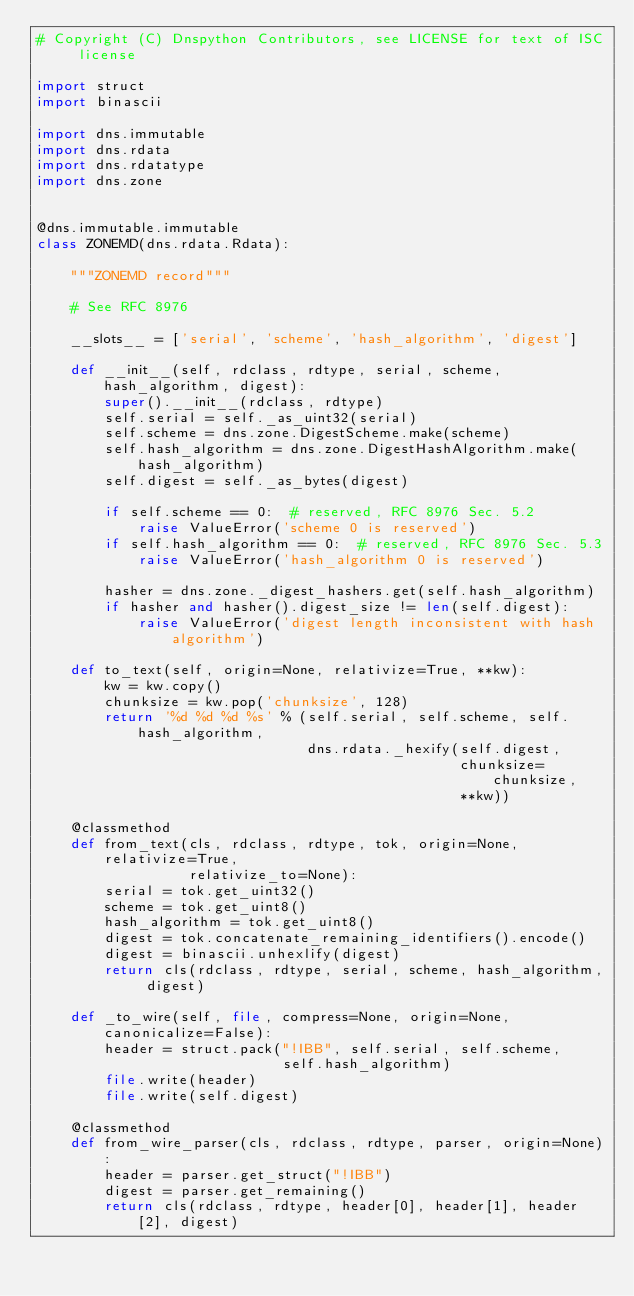Convert code to text. <code><loc_0><loc_0><loc_500><loc_500><_Python_># Copyright (C) Dnspython Contributors, see LICENSE for text of ISC license

import struct
import binascii

import dns.immutable
import dns.rdata
import dns.rdatatype
import dns.zone


@dns.immutable.immutable
class ZONEMD(dns.rdata.Rdata):

    """ZONEMD record"""

    # See RFC 8976

    __slots__ = ['serial', 'scheme', 'hash_algorithm', 'digest']

    def __init__(self, rdclass, rdtype, serial, scheme, hash_algorithm, digest):
        super().__init__(rdclass, rdtype)
        self.serial = self._as_uint32(serial)
        self.scheme = dns.zone.DigestScheme.make(scheme)
        self.hash_algorithm = dns.zone.DigestHashAlgorithm.make(hash_algorithm)
        self.digest = self._as_bytes(digest)

        if self.scheme == 0:  # reserved, RFC 8976 Sec. 5.2
            raise ValueError('scheme 0 is reserved')
        if self.hash_algorithm == 0:  # reserved, RFC 8976 Sec. 5.3
            raise ValueError('hash_algorithm 0 is reserved')

        hasher = dns.zone._digest_hashers.get(self.hash_algorithm)
        if hasher and hasher().digest_size != len(self.digest):
            raise ValueError('digest length inconsistent with hash algorithm')

    def to_text(self, origin=None, relativize=True, **kw):
        kw = kw.copy()
        chunksize = kw.pop('chunksize', 128)
        return '%d %d %d %s' % (self.serial, self.scheme, self.hash_algorithm,
                                dns.rdata._hexify(self.digest,
                                                  chunksize=chunksize,
                                                  **kw))

    @classmethod
    def from_text(cls, rdclass, rdtype, tok, origin=None, relativize=True,
                  relativize_to=None):
        serial = tok.get_uint32()
        scheme = tok.get_uint8()
        hash_algorithm = tok.get_uint8()
        digest = tok.concatenate_remaining_identifiers().encode()
        digest = binascii.unhexlify(digest)
        return cls(rdclass, rdtype, serial, scheme, hash_algorithm, digest)

    def _to_wire(self, file, compress=None, origin=None, canonicalize=False):
        header = struct.pack("!IBB", self.serial, self.scheme,
                             self.hash_algorithm)
        file.write(header)
        file.write(self.digest)

    @classmethod
    def from_wire_parser(cls, rdclass, rdtype, parser, origin=None):
        header = parser.get_struct("!IBB")
        digest = parser.get_remaining()
        return cls(rdclass, rdtype, header[0], header[1], header[2], digest)
</code> 